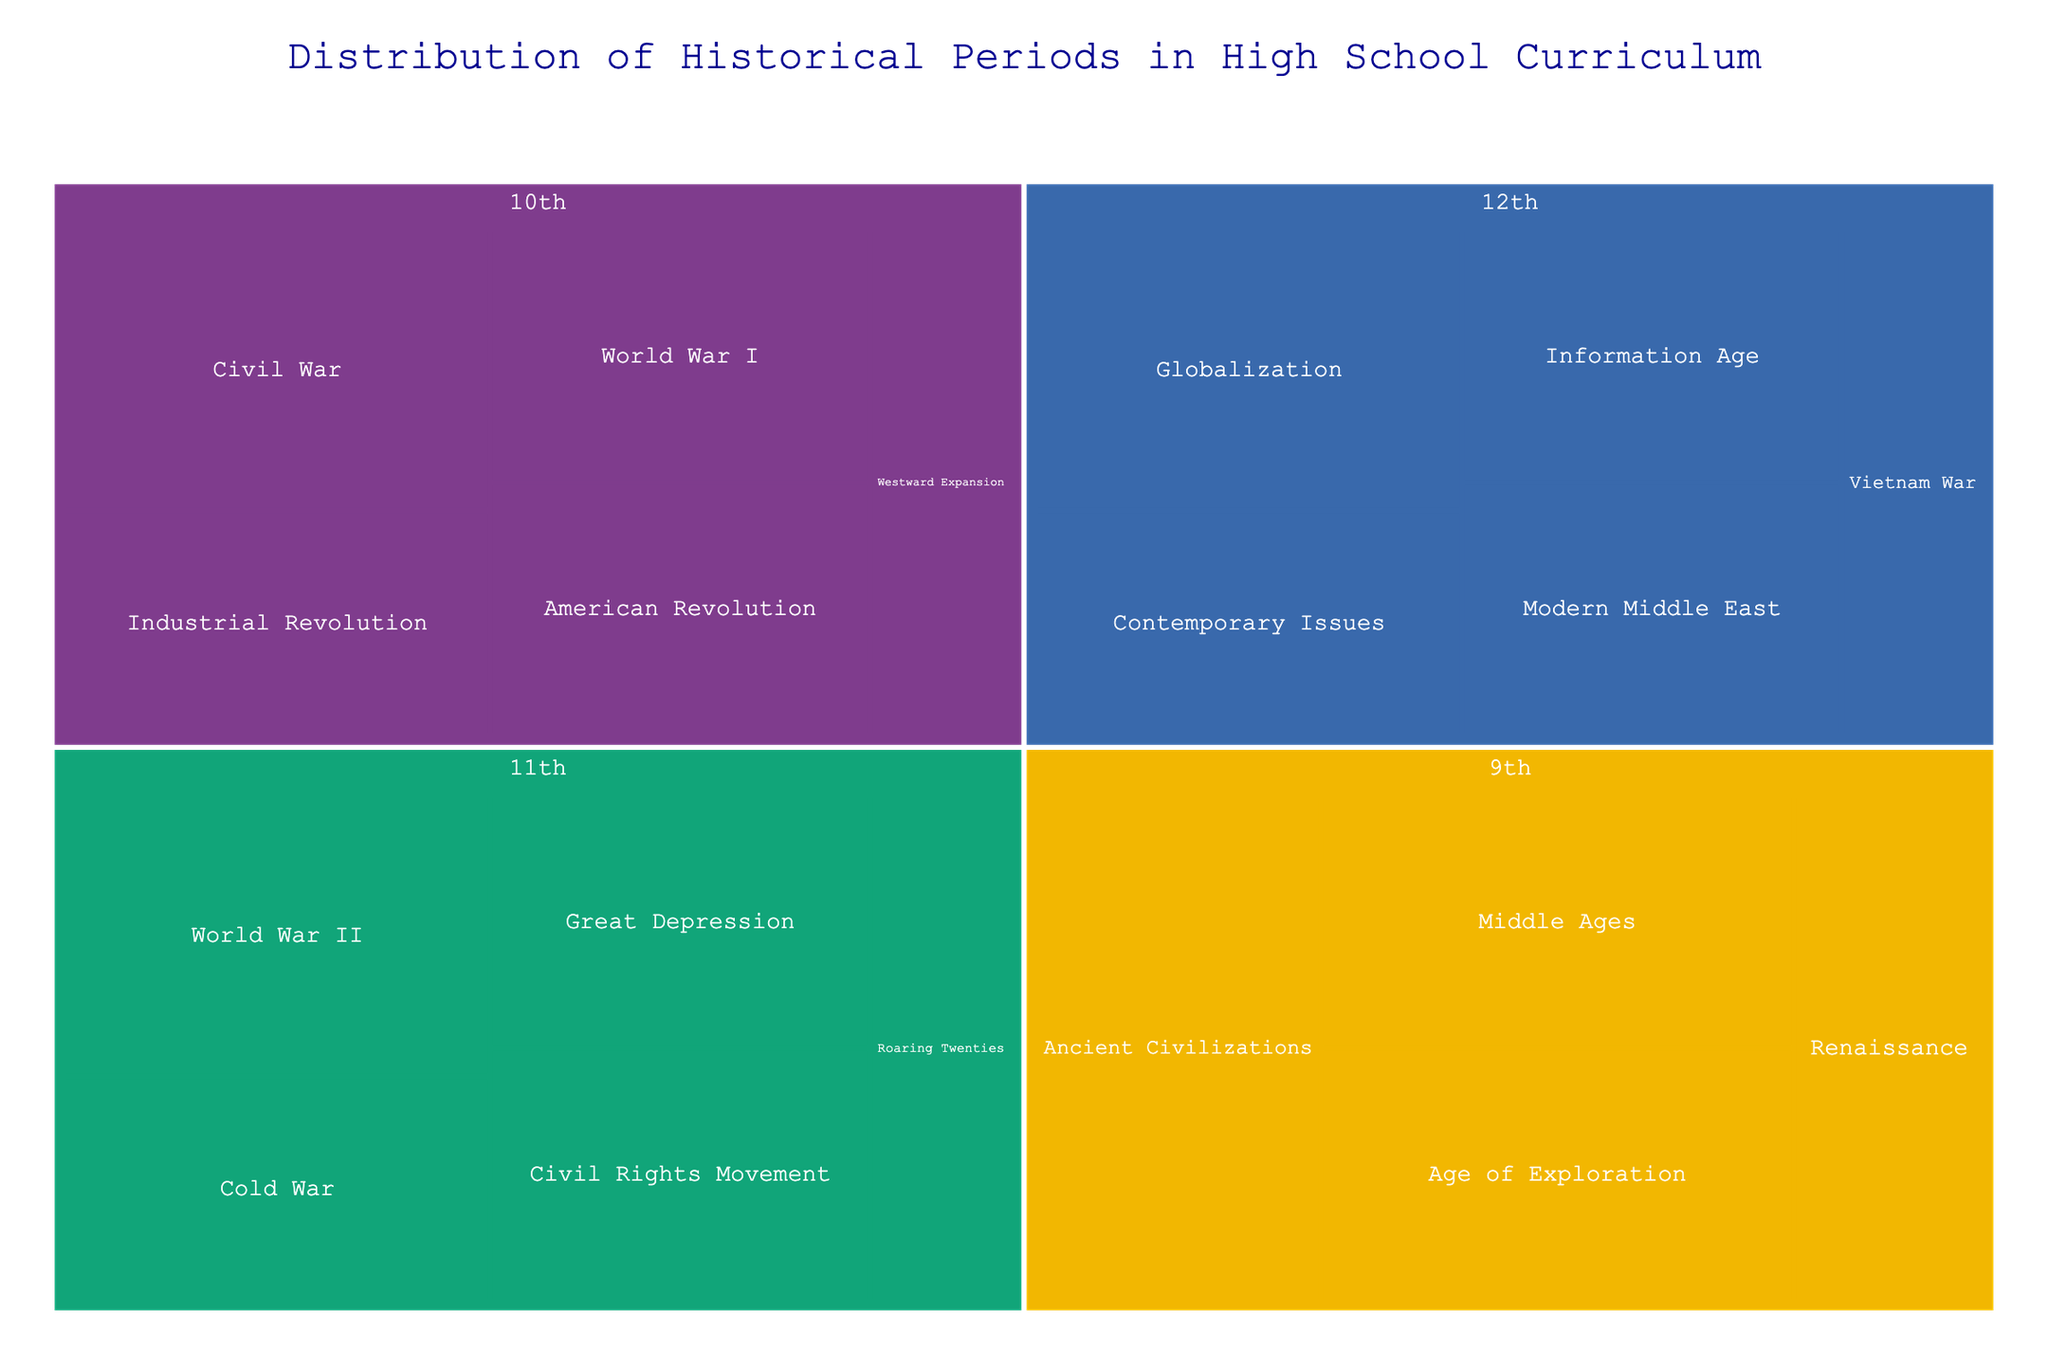What is the title of the treemap? The title of the treemap is prominently displayed at the top and clearly provides insight into the main topic being visualized.
Answer: Distribution of Historical Periods in High School Curriculum Which historical period is covered the most in the 9th grade curriculum? By analyzing the sizes and labels of the segments in the 9th-grade category, we can identify which period has the largest representation.
Answer: Ancient Civilizations What percentage of the 10th grade curriculum covers the American Revolution? Find the segment labeled "American Revolution" under the 10th grade and refer to the percentage label included in that segment.
Answer: 20% Compare the coverage of World War II and the Great Depression in the 11th grade curriculum. Which has a higher percentage? Locate the segments for World War II and the Great Depression in the 11th grade section and compare their respective percentages.
Answer: World War II Is there any historical period that appears in multiple grades? Scan the labels within each grade section to identify if any period is repeated across different grades.
Answer: No What percentage of the 12th-grade curriculum is dedicated to Contemporary Issues? Locate the "Contemporary Issues" segment under the 12th grade and note the percentage from the visual representation.
Answer: 20% Which grade covers the Cold War, and what is the percentage? Identify the grade section that contains the "Cold War" segment and note the percentage displayed within that segment.
Answer: 11th grade, 20% Sum the percentages of Industrial Revolution and World War I in the 10th grade curriculum. Find the percentages for "Industrial Revolution" and "World War I" in the 10th grade segments, then add them together.
Answer: 40% Calculate the average percentage of the historical periods covered in the 12th grade. Add the percentages of all historical periods listed under the 12th grade, then divide by the number of periods. Total = 15 + 20 + 25 + 20 + 20 = 100; Average = 100 / 5
Answer: 20% Which historical period has the smallest coverage in the 11th-grade curriculum? Look within the 11th-grade section and identify the period with the smallest segment or lowest percentage.
Answer: Roaring Twenties 